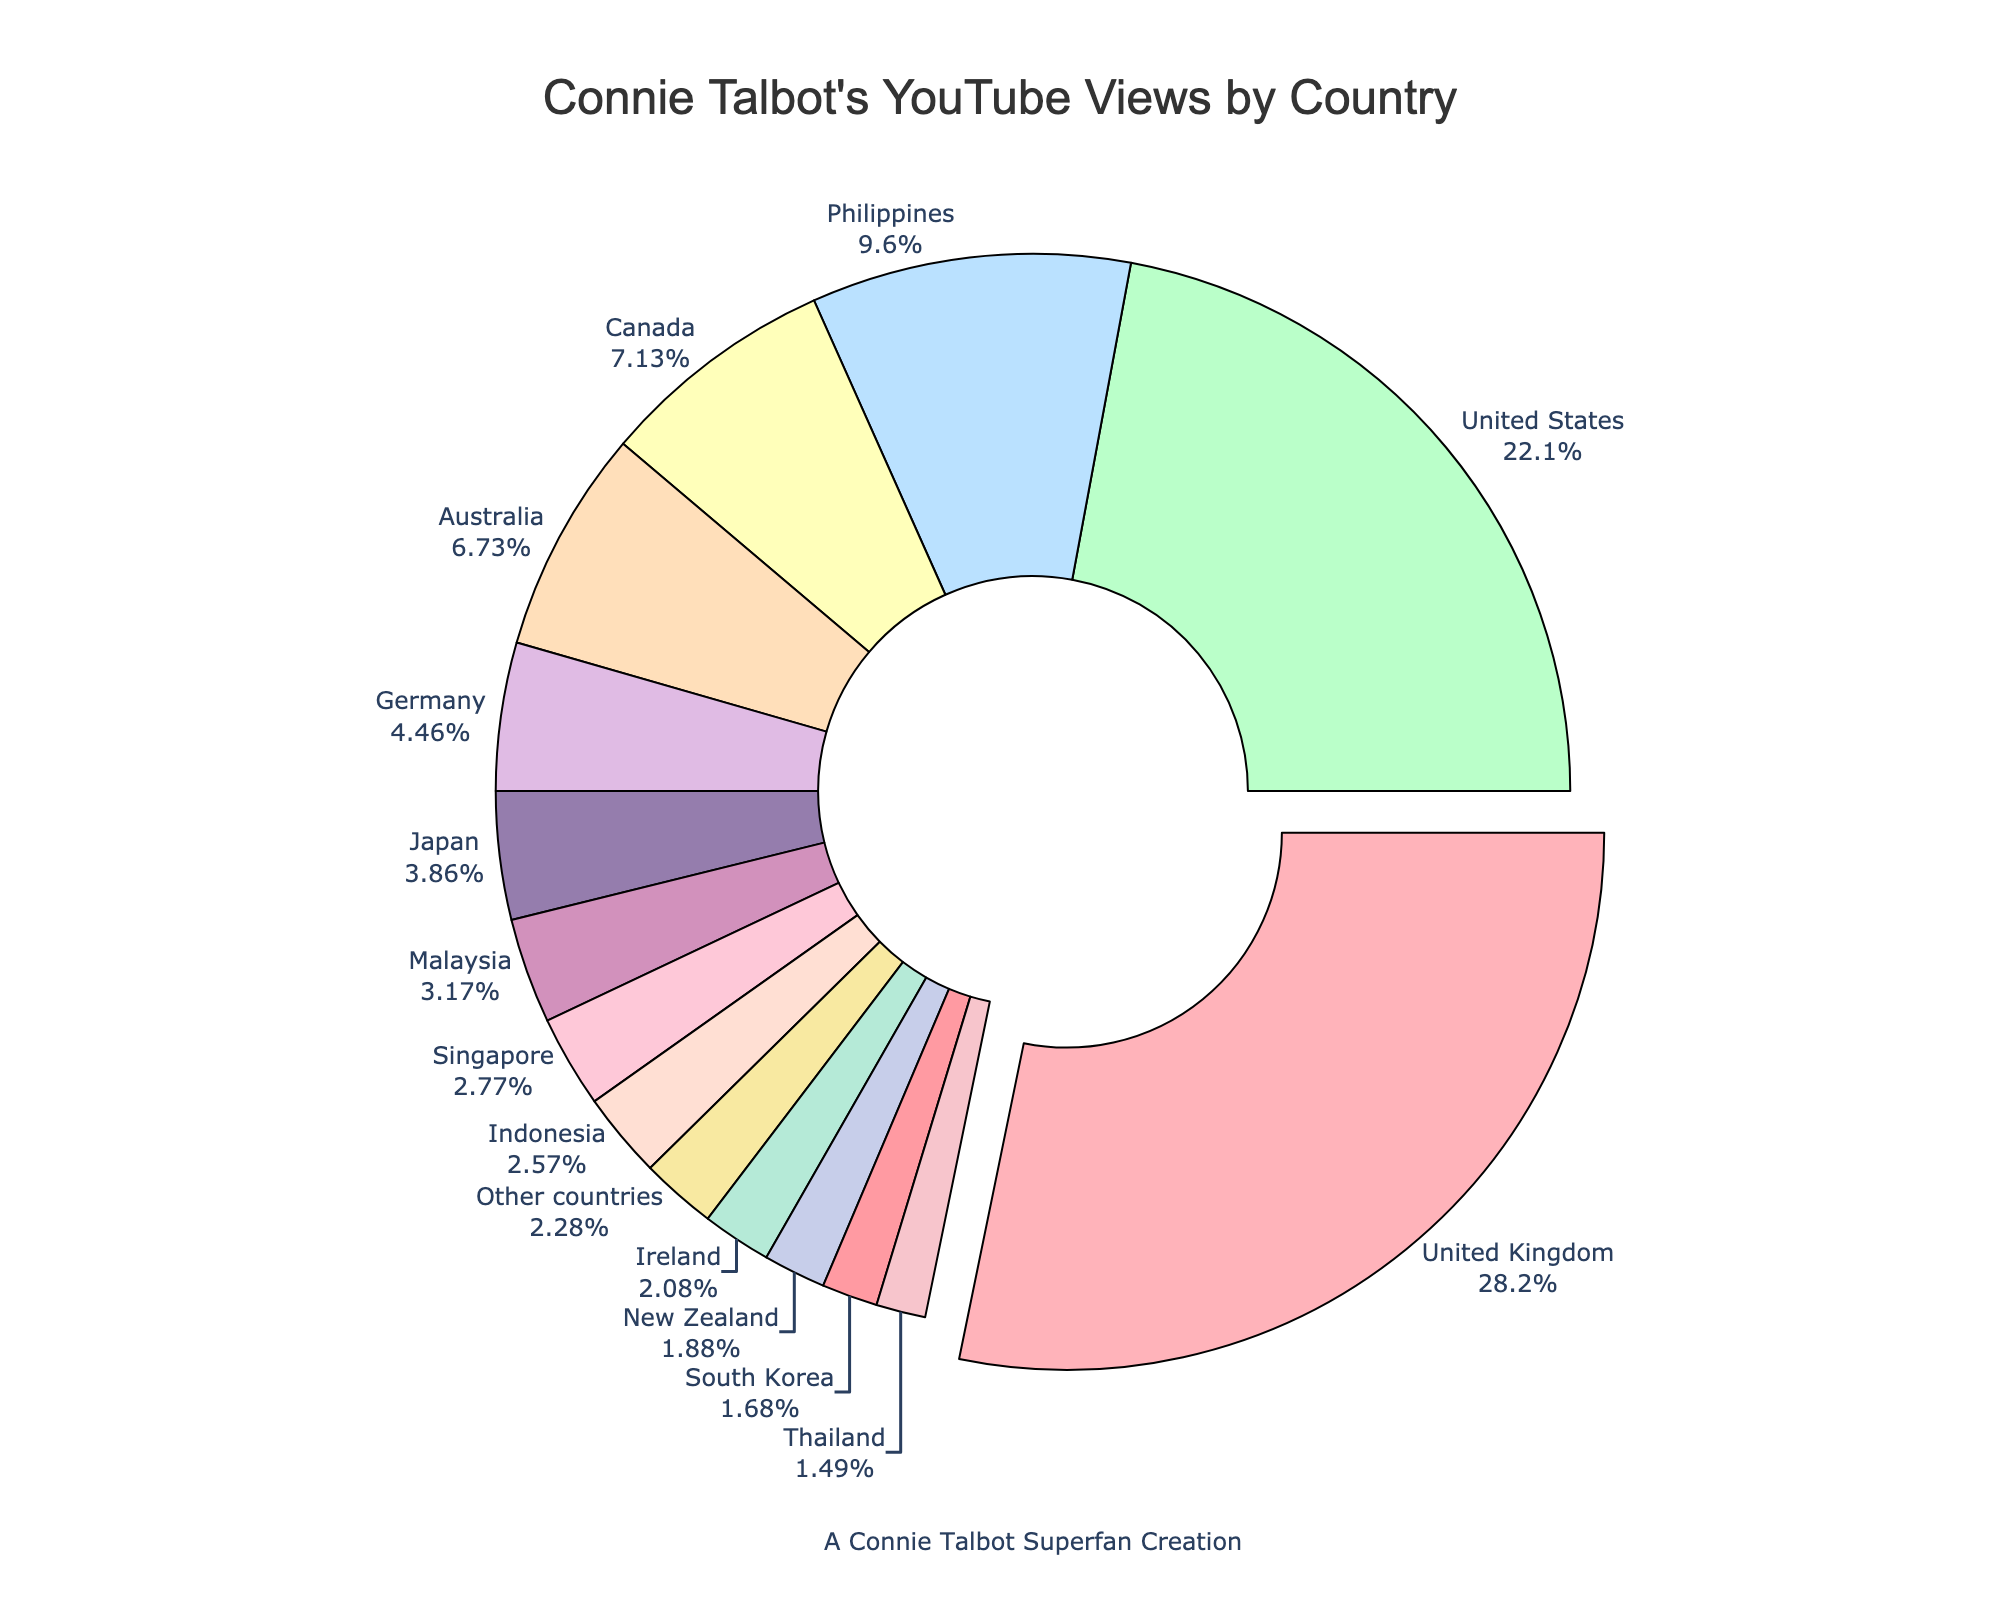How much percentage of Connie Talbot's YouTube views come from the United Kingdom and the United States combined? Add the percentages of views from the United Kingdom (28.5%) and the United States (22.3%): 28.5 + 22.3 = 50.8.
Answer: 50.8% Which country has the highest percentage of Connie Talbot's YouTube views, and what is that percentage? The country with the largest segment of the pie chart is the United Kingdom, which has a percentage of 28.5%.
Answer: United Kingdom, 28.5% What is the combined percentage of YouTube views from Japan and South Korea? Add the percentages of views from Japan (3.9%) and South Korea (1.7%): 3.9 + 1.7 = 5.6.
Answer: 5.6% Which country has the smallest percentage of Connie Talbot's YouTube views, and what is that percentage? The segment with the lowest percentage in the pie chart is South Korea, with a percentage of 1.5%.
Answer: South Korea, 1.5% How does the percentage of views from Germany compare to that from Canada? Compare Germany's 4.5% to Canada's 7.2%: 4.5% is less than 7.2%.
Answer: Germany's percentage is less What is the average percentage of views from the Philippines, Malaysia, and Indonesia? Calculate the average: (9.7 + 3.2 + 2.6) / 3 = 15.5 / 3 = 5.167.
Answer: 5.167% Are there more views from Malaysia or Indonesia? Compare the percentages: Malaysia (3.2%) and Indonesia (2.6%): 3.2% is greater than 2.6%.
Answer: Malaysia Which country outside of the United Kingdom and the United States has the highest percentage of views? The highest percentage after the United Kingdom and the United States is the Philippines with 9.7%.
Answer: Philippines What is the total percentage of views from Australia, Canada, and the Philippines? Add the percentages: Australia (6.8%) + Canada (7.2%) + Philippines (9.7%) = 6.8 + 7.2 + 9.7 = 23.7.
Answer: 23.7% What is the median percentage value of Connie Talbot's YouTube views by country? List the percentages in ascending order: 1.5%, 1.7%, 1.9%, 2.1%, 2.3%, 2.6%, 2.8%, 3.2%, 3.9%, 4.5%, 6.8%, 7.2%, 9.7%, 22.3%, 28.5%. The middle value (8th in the list) is 3.2% from Malaysia.
Answer: 3.2% 